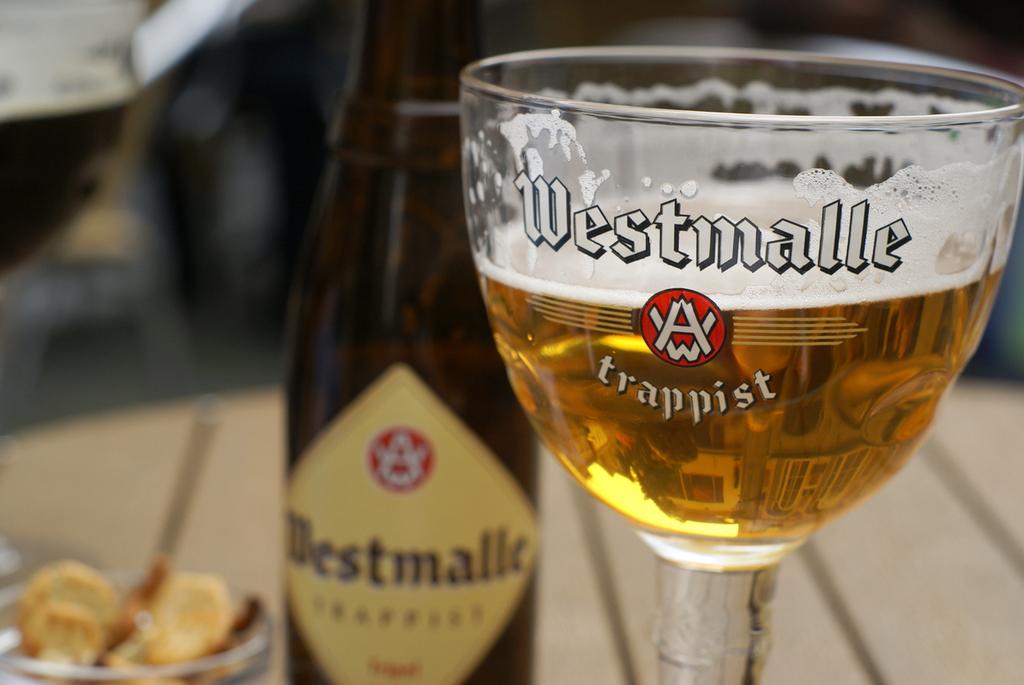What does the text below the logo say on the cup?
Keep it short and to the point. Trappist. 